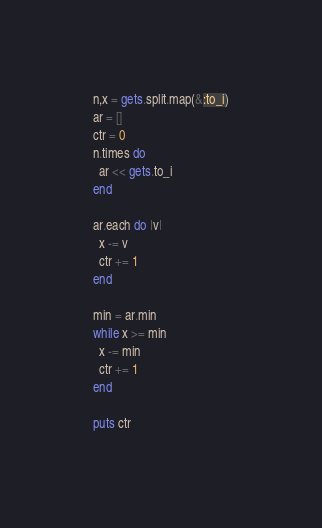Convert code to text. <code><loc_0><loc_0><loc_500><loc_500><_Ruby_>n,x = gets.split.map(&:to_i)
ar = []
ctr = 0
n.times do
  ar << gets.to_i
end

ar.each do |v|
  x -= v
  ctr += 1
end

min = ar.min
while x >= min
  x -= min
  ctr += 1
end

puts ctr
</code> 